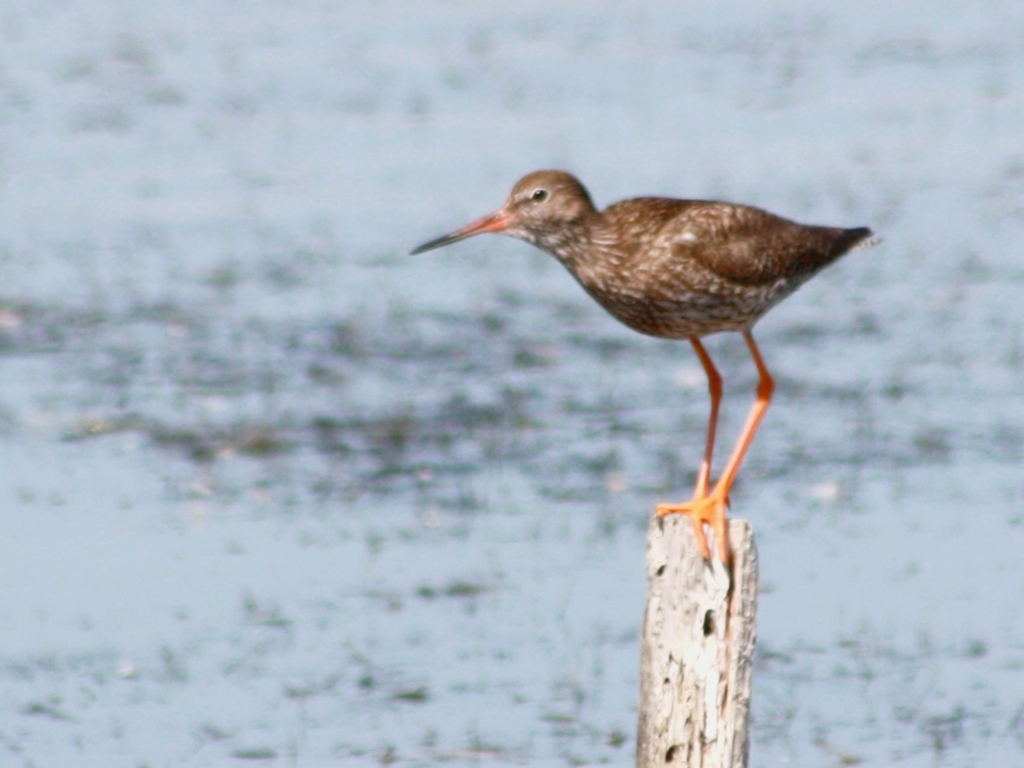What species of bird is this, and can you tell if it's common in its habitat? The bird appears to be a type of shorebird, known for their long legs and beaks which they use to forage in mudflats and shorelines. I'm not able to provide exact species identification, but birds like this are often found in wetland habitats and can be quite common depending on the species and the region. To determine the species, one would typically consider location, bird calls, and more specific markings which aren't discernible in this image. 